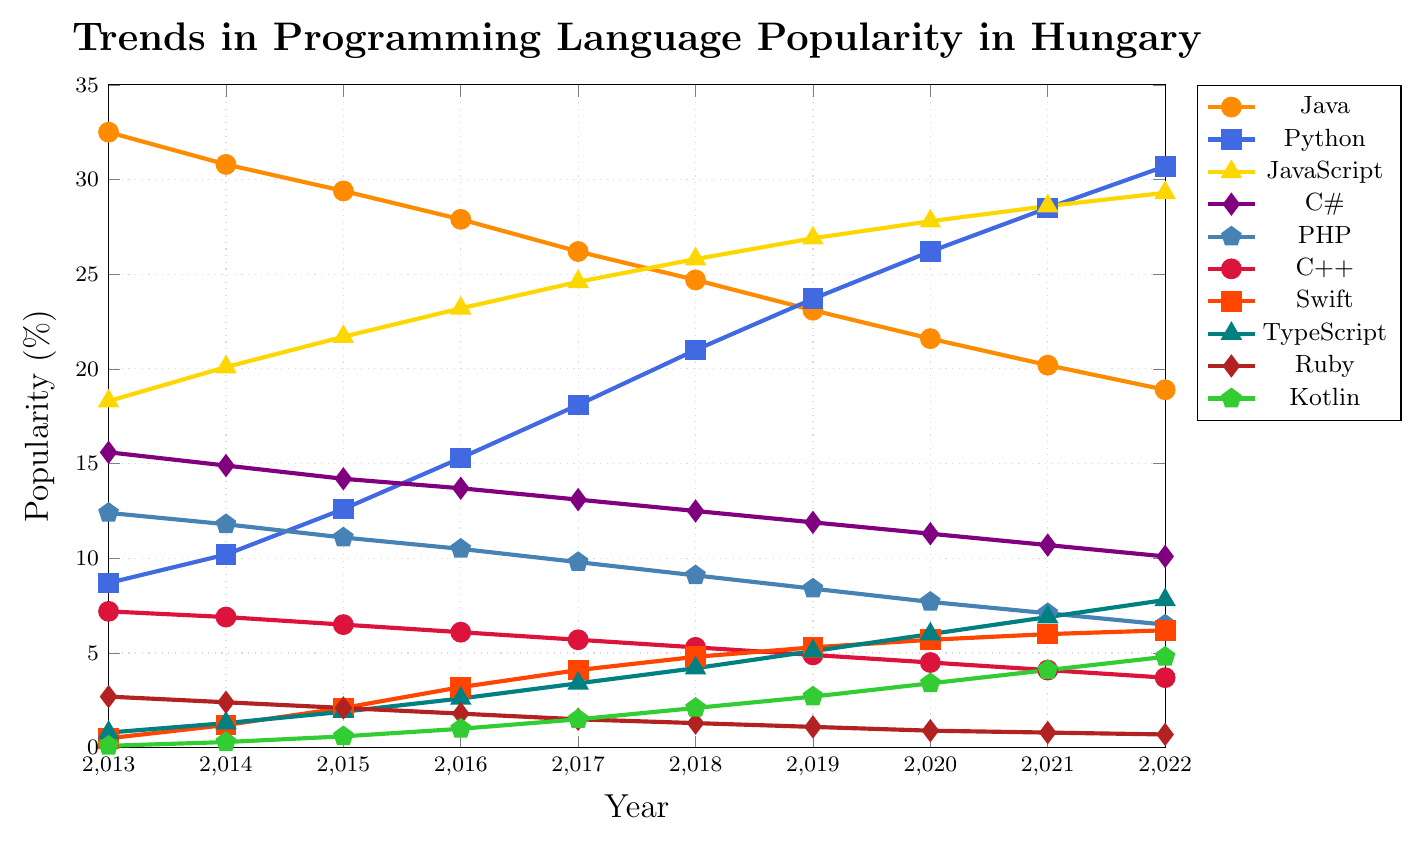Which programming language had the highest popularity in 2013? The figure shows that in 2013, Java had the highest popularity among the programming languages listed.
Answer: Java How did the popularity of Python change from 2013 to 2022? Python's popularity increased steadily each year from 8.7% in 2013 to 30.7% in 2022.
Answer: Increased Which two languages had the closest popularity levels in 2022, and what were those levels? In 2022, Kotlin and Swift had the closest popularity levels, with Kotlin at 4.8% and Swift at 6.2%.
Answer: Kotlin (4.8%) and Swift (6.2%) By how much did the popularity of JavaScript increase from 2013 to 2022? The popularity of JavaScript increased from 18.3% in 2013 to 29.3% in 2022. So, the increase is 29.3% - 18.3% = 11.0%.
Answer: 11.0% In which year did Python surpass Java in popularity? Python surpassed Java in popularity between 2019 and 2020. In 2020, Python's popularity was 26.2%, and Java's was 21.6%.
Answer: 2020 Which language showed a continuous decline in popularity every year? PHP showed a continuous decline in popularity every year from 2013 to 2022.
Answer: PHP What is the average popularity of C# from 2013 to 2022? Sum the popularity percentages of C# from 2013 to 2022: (15.6 + 14.9 + 14.2 + 13.7 + 13.1 + 12.5 + 11.9 + 11.3 + 10.7 + 10.1) = 128. Then, divide by the number of years (10): 128 / 10 = 12.8.
Answer: 12.8 Which language had the highest growth rate between 2013 and 2022? To determine the highest growth rate, compare the difference between the 2022 popularity and the 2013 popularity for each language. Python grew from 8.7% to 30.7%, an increase of 22.0%, which is the highest among the languages.
Answer: Python Comparing 2013 to 2022, which language had the smallest change in popularity? Ruby had the smallest change in popularity, decreasing from 2.7% in 2013 to 0.7% in 2022, a change of -2.0%.
Answer: Ruby Rank JavaScript, TypeScript, and Swift by their 2022 popularity. In 2022, JavaScript had 29.3%, TypeScript had 7.8%, and Swift had 6.2%. Ranking them from highest to lowest popularity: JavaScript, TypeScript, Swift.
Answer: JavaScript, TypeScript, Swift 